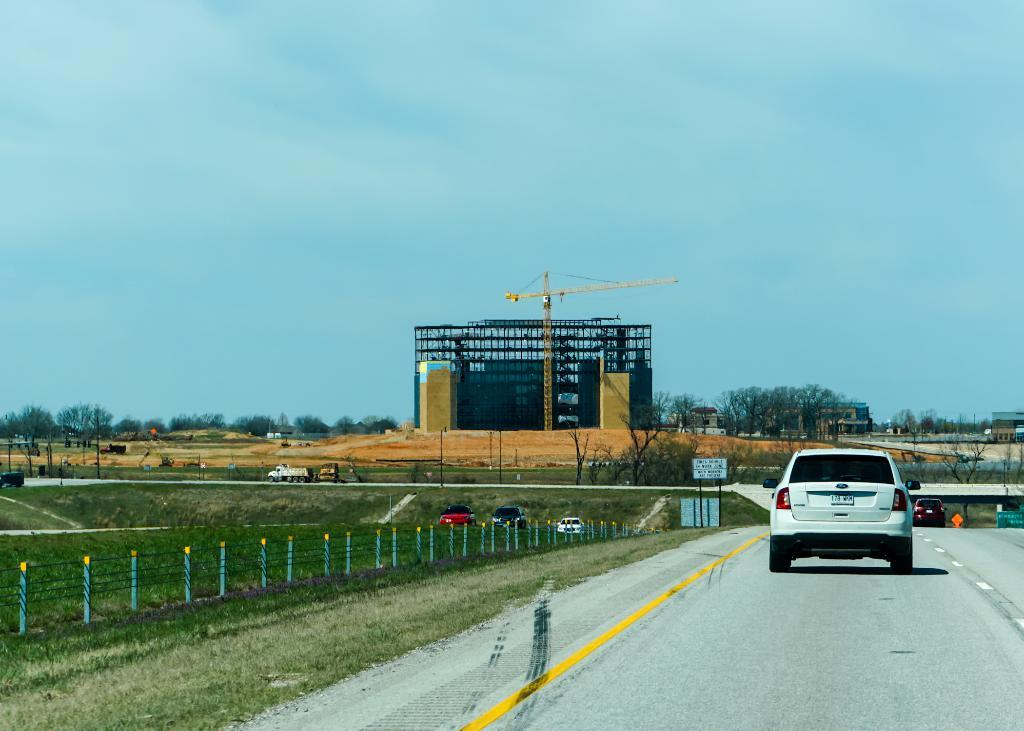What is happening on the road in the image? There are vehicles on the road in the image. What type of vegetation can be seen at the side of the road? There is grass visible at the side of the road. What is separating the road from the grass? There is a fence at the side of the road. What are the boards at the side of the road used for? The boards at the side of the road might be used for advertising or displaying information. What can be seen in the background of the image? There are buildings, a crane, trees, and the sky visible in the background. How many clover leaves can be seen growing on the side of the road in the image? There is no clover visible in the image; only grass is mentioned. What type of snails are crawling on the vehicles in the image? There are no snails visible in the image; only vehicles are mentioned. 